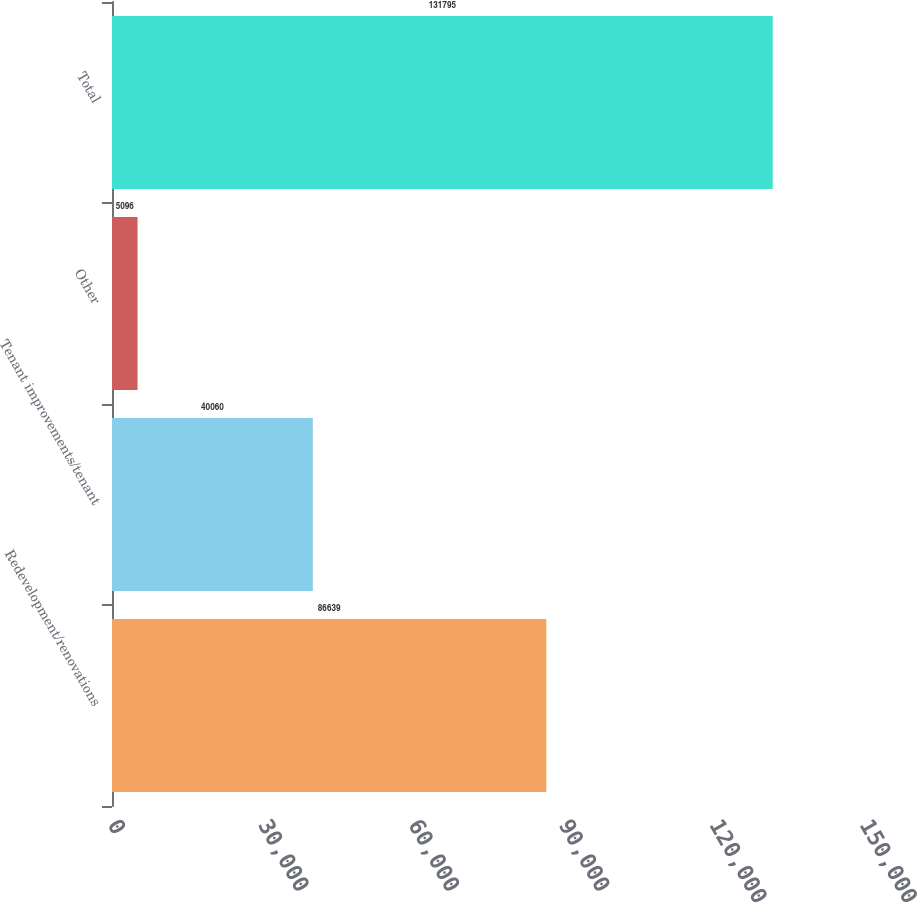Convert chart. <chart><loc_0><loc_0><loc_500><loc_500><bar_chart><fcel>Redevelopment/renovations<fcel>Tenant improvements/tenant<fcel>Other<fcel>Total<nl><fcel>86639<fcel>40060<fcel>5096<fcel>131795<nl></chart> 